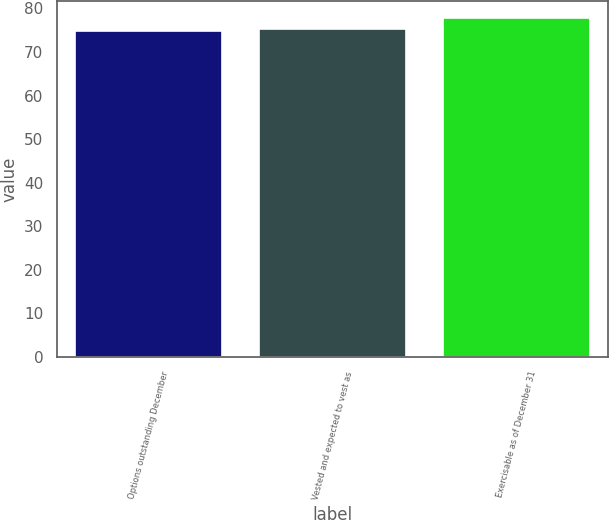Convert chart to OTSL. <chart><loc_0><loc_0><loc_500><loc_500><bar_chart><fcel>Options outstanding December<fcel>Vested and expected to vest as<fcel>Exercisable as of December 31<nl><fcel>74.87<fcel>75.16<fcel>77.78<nl></chart> 